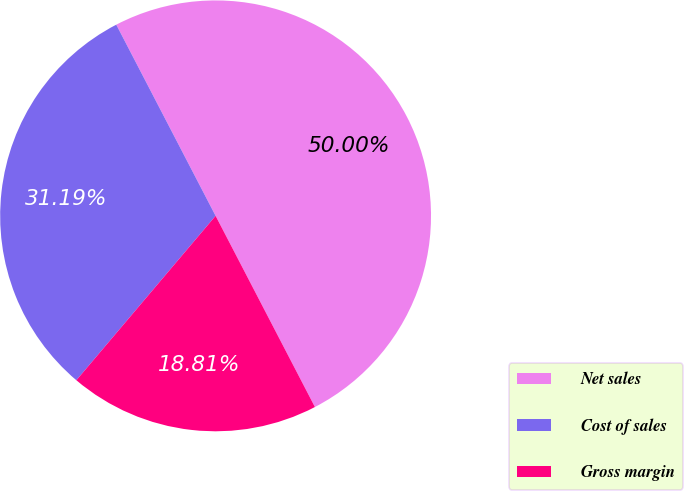Convert chart to OTSL. <chart><loc_0><loc_0><loc_500><loc_500><pie_chart><fcel>Net sales<fcel>Cost of sales<fcel>Gross margin<nl><fcel>50.0%<fcel>31.19%<fcel>18.81%<nl></chart> 